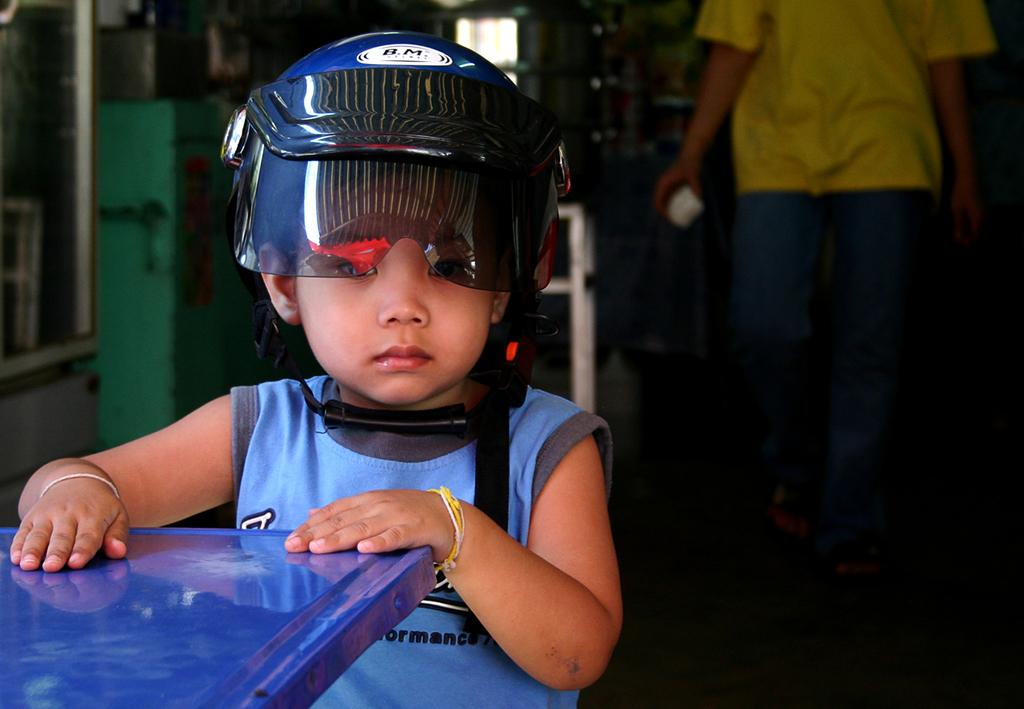What is the boy in the image doing? The boy is sitting in the image. What is the boy wearing on his head? The boy is wearing a helmet. What object is in front of the boy? There is a table in front of the boy. Can you describe the person standing at the back of the image? The person standing at the back of the image is wearing a yellow t-shirt. What type of cup is the boy holding in the image? There is no cup visible in the image; the boy is wearing a helmet. What is the person cooking in the image? There is no person cooking in the image; the person standing at the back is wearing a yellow t-shirt. 